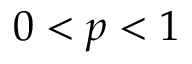Convert formula to latex. <formula><loc_0><loc_0><loc_500><loc_500>0 < p < 1</formula> 